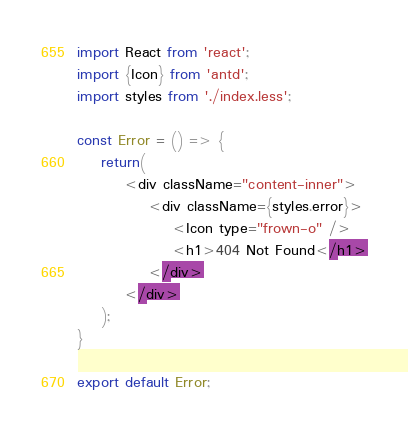<code> <loc_0><loc_0><loc_500><loc_500><_JavaScript_>import React from 'react';
import {Icon} from 'antd';
import styles from './index.less';

const Error = () => {
    return(
        <div className="content-inner">
            <div className={styles.error}>
                <Icon type="frown-o" />
                <h1>404 Not Found</h1>
            </div>
        </div>
    );
}

export default Error;
</code> 